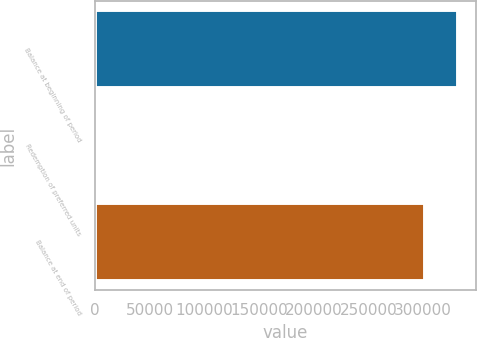<chart> <loc_0><loc_0><loc_500><loc_500><bar_chart><fcel>Balance at beginning of period<fcel>Redemption of preferred units<fcel>Balance at end of period<nl><fcel>331908<fcel>275<fcel>301735<nl></chart> 